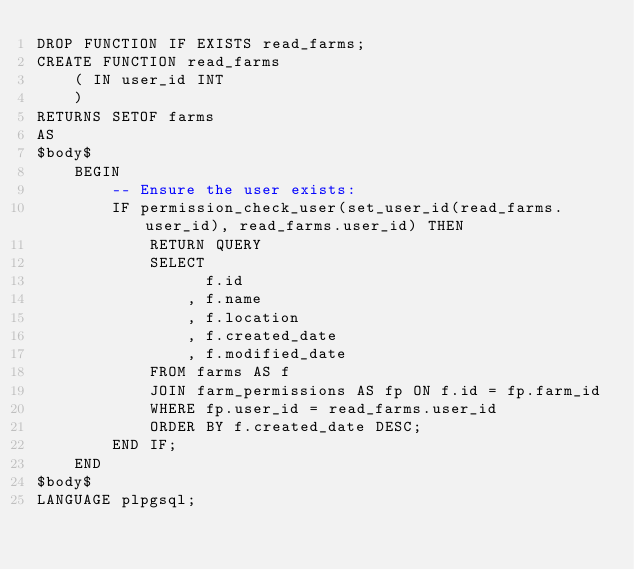Convert code to text. <code><loc_0><loc_0><loc_500><loc_500><_SQL_>DROP FUNCTION IF EXISTS read_farms;
CREATE FUNCTION read_farms
	( IN user_id INT
	)
RETURNS SETOF farms
AS
$body$
	BEGIN
		-- Ensure the user exists:
		IF permission_check_user(set_user_id(read_farms.user_id), read_farms.user_id) THEN
			RETURN QUERY
			SELECT
				  f.id
				, f.name
				, f.location
				, f.created_date
				, f.modified_date
			FROM farms AS f
			JOIN farm_permissions AS fp ON f.id = fp.farm_id
			WHERE fp.user_id = read_farms.user_id
			ORDER BY f.created_date DESC;
		END IF;
	END
$body$
LANGUAGE plpgsql;
</code> 